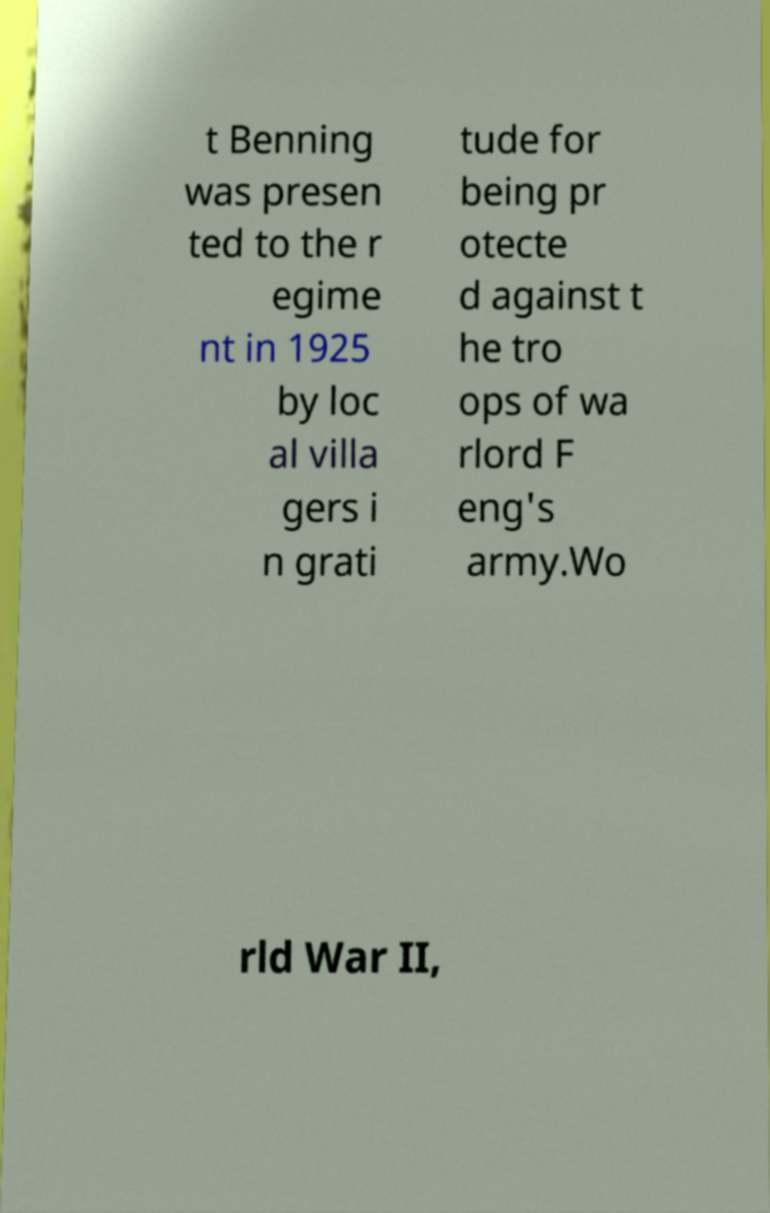Can you read and provide the text displayed in the image?This photo seems to have some interesting text. Can you extract and type it out for me? t Benning was presen ted to the r egime nt in 1925 by loc al villa gers i n grati tude for being pr otecte d against t he tro ops of wa rlord F eng's army.Wo rld War II, 